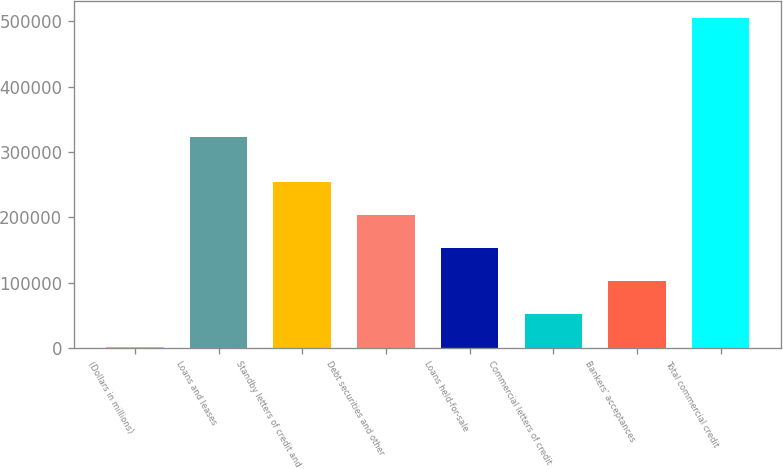Convert chart. <chart><loc_0><loc_0><loc_500><loc_500><bar_chart><fcel>(Dollars in millions)<fcel>Loans and leases<fcel>Standby letters of credit and<fcel>Debt securities and other<fcel>Loans held-for-sale<fcel>Commercial letters of credit<fcel>Bankers' acceptances<fcel>Total commercial credit<nl><fcel>2009<fcel>322564<fcel>253753<fcel>203404<fcel>153055<fcel>52357.8<fcel>102707<fcel>505497<nl></chart> 